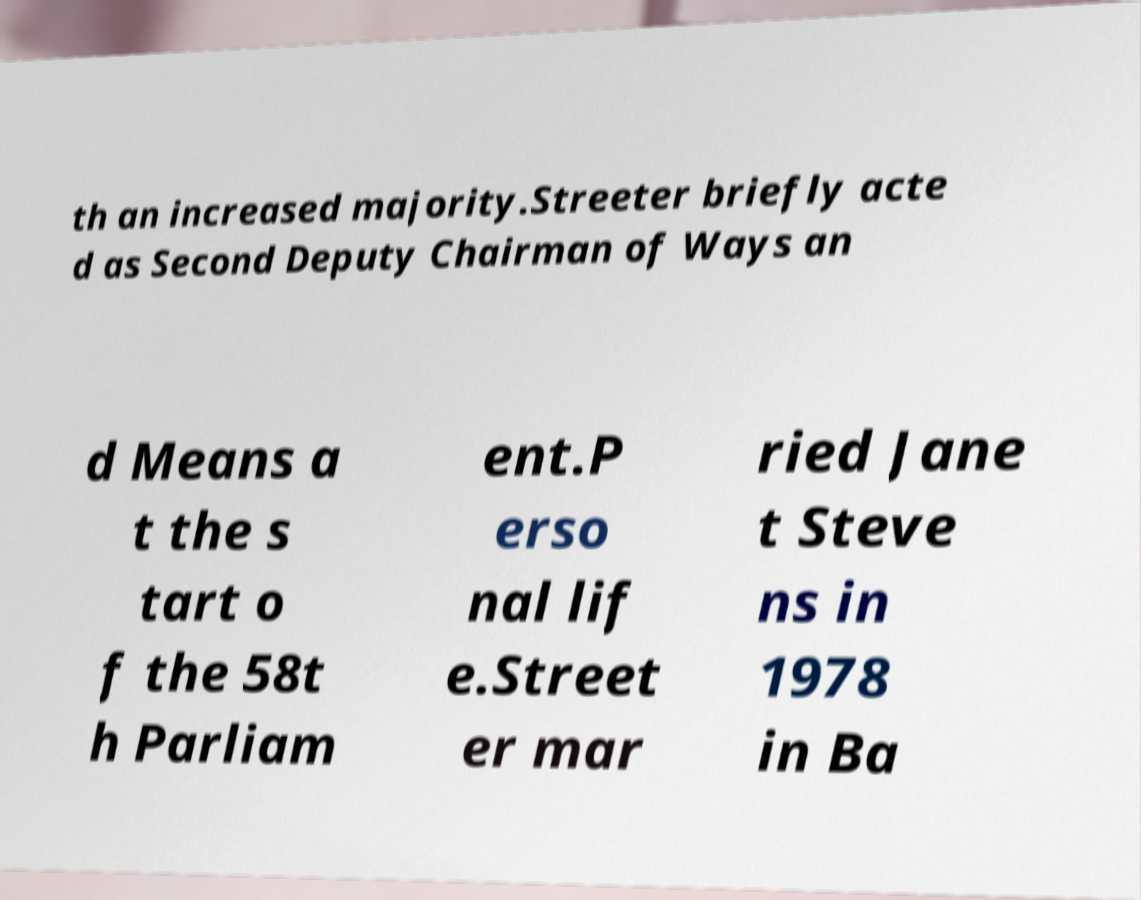Please identify and transcribe the text found in this image. th an increased majority.Streeter briefly acte d as Second Deputy Chairman of Ways an d Means a t the s tart o f the 58t h Parliam ent.P erso nal lif e.Street er mar ried Jane t Steve ns in 1978 in Ba 